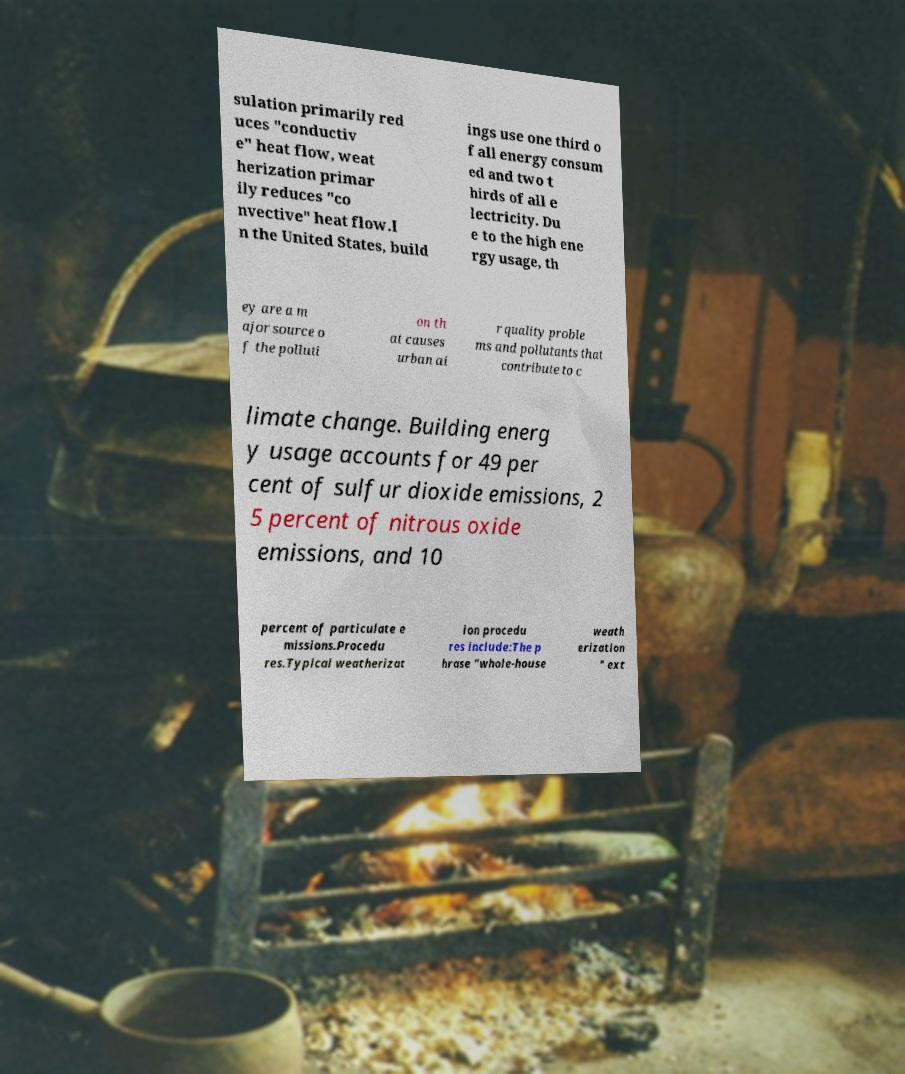There's text embedded in this image that I need extracted. Can you transcribe it verbatim? sulation primarily red uces "conductiv e" heat flow, weat herization primar ily reduces "co nvective" heat flow.I n the United States, build ings use one third o f all energy consum ed and two t hirds of all e lectricity. Du e to the high ene rgy usage, th ey are a m ajor source o f the polluti on th at causes urban ai r quality proble ms and pollutants that contribute to c limate change. Building energ y usage accounts for 49 per cent of sulfur dioxide emissions, 2 5 percent of nitrous oxide emissions, and 10 percent of particulate e missions.Procedu res.Typical weatherizat ion procedu res include:The p hrase "whole-house weath erization " ext 